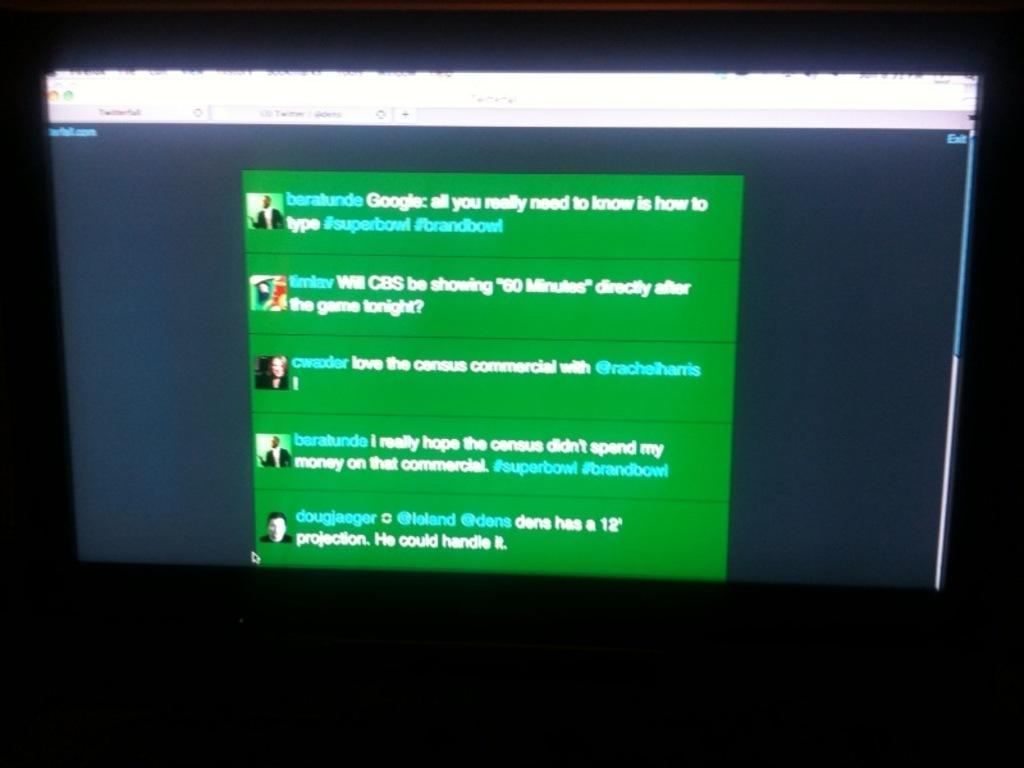<image>
Describe the image concisely. The first message on the screen is by Baralunde 